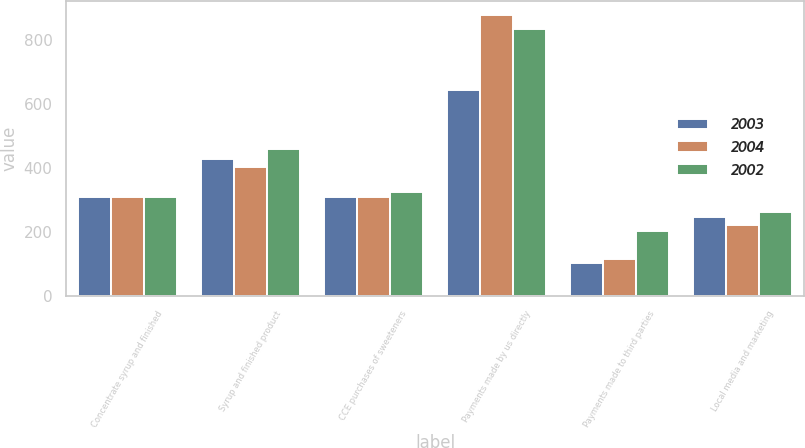Convert chart to OTSL. <chart><loc_0><loc_0><loc_500><loc_500><stacked_bar_chart><ecel><fcel>Concentrate syrup and finished<fcel>Syrup and finished product<fcel>CCE purchases of sweeteners<fcel>Payments made by us directly<fcel>Payments made to third parties<fcel>Local media and marketing<nl><fcel>2003<fcel>311<fcel>428<fcel>309<fcel>646<fcel>104<fcel>246<nl><fcel>2004<fcel>311<fcel>403<fcel>311<fcel>880<fcel>115<fcel>221<nl><fcel>2002<fcel>311<fcel>461<fcel>325<fcel>837<fcel>204<fcel>264<nl></chart> 